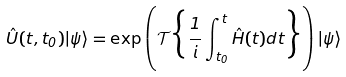<formula> <loc_0><loc_0><loc_500><loc_500>\hat { U } ( t , t _ { 0 } ) | \psi \rangle = \exp \left ( \mathcal { T } \Big { \{ } \frac { 1 } { i } \int ^ { t } _ { t _ { 0 } } \hat { H } ( t ) d t \Big { \} } \right ) | \psi \rangle</formula> 